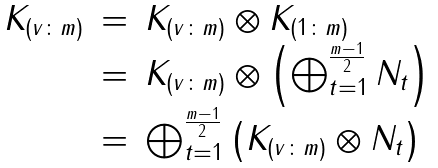<formula> <loc_0><loc_0><loc_500><loc_500>\begin{array} { c c l } K _ { ( v \colon m ) } & = & K _ { ( v \colon m ) } \otimes K _ { ( 1 \colon m ) } \\ & = & K _ { ( v \colon m ) } \otimes \left ( \bigoplus _ { t = 1 } ^ { \frac { m - 1 } { 2 } } N _ { t } \right ) \\ & = & \bigoplus _ { t = 1 } ^ { \frac { m - 1 } { 2 } } \left ( K _ { ( v \colon m ) } \otimes N _ { t } \right ) \\ \end{array}</formula> 